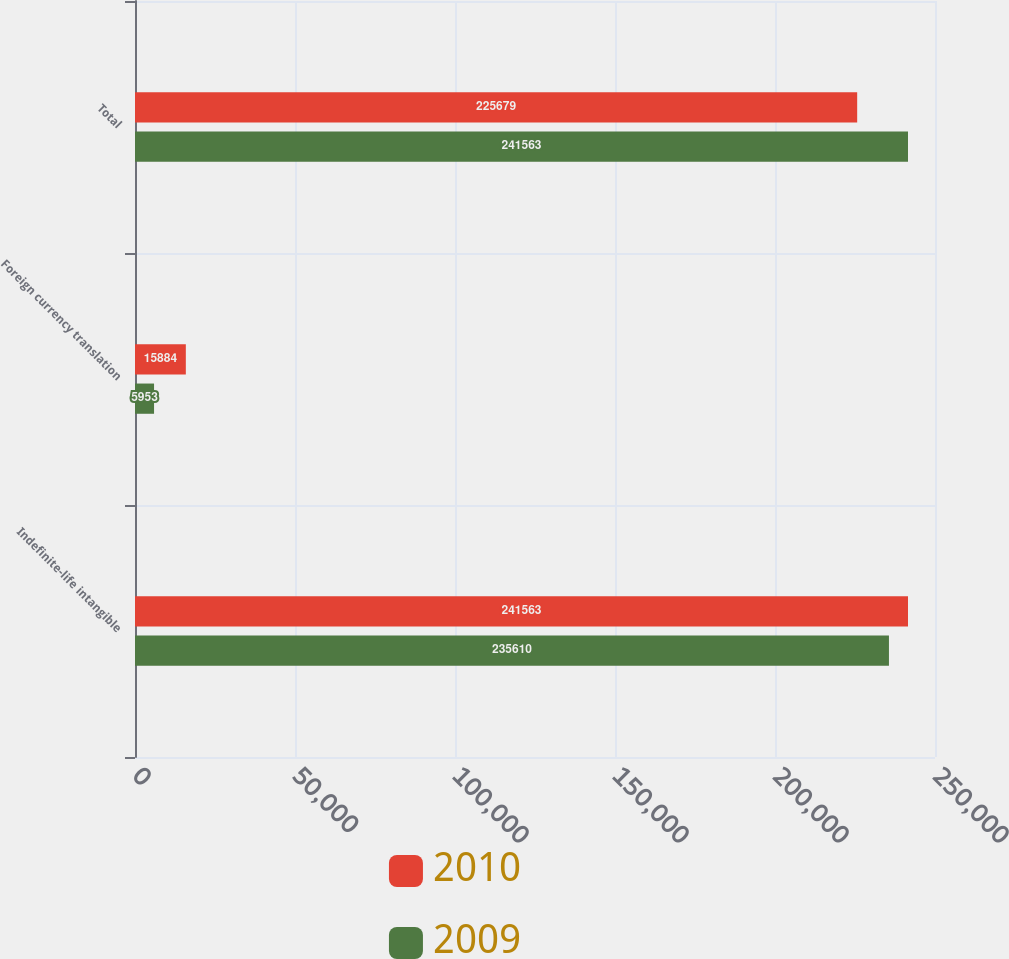Convert chart to OTSL. <chart><loc_0><loc_0><loc_500><loc_500><stacked_bar_chart><ecel><fcel>Indefinite-life intangible<fcel>Foreign currency translation<fcel>Total<nl><fcel>2010<fcel>241563<fcel>15884<fcel>225679<nl><fcel>2009<fcel>235610<fcel>5953<fcel>241563<nl></chart> 